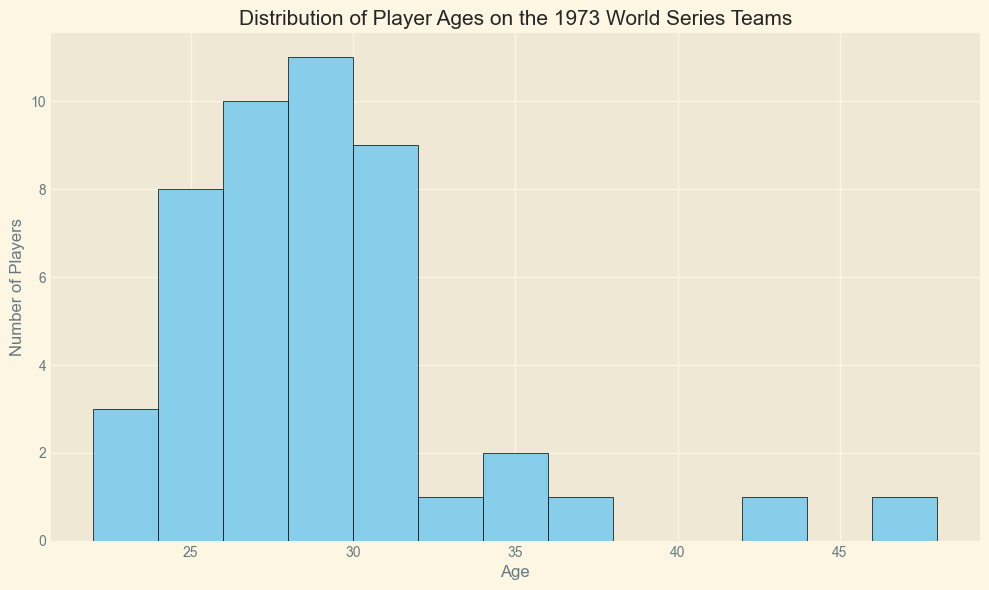What is the most common age among the players? By looking at the histogram, the age bin with the highest bar indicates the most common age. Count the bins and observe that the bar for age 29 is the tallest.
Answer: 29 How many players are 30 years old? Look at the height of the bar corresponding to the age bin that includes age 30. This bar reaches to 4 players.
Answer: 4 What is the age range of the players depicted in the histogram? Identify the lowest and highest age bins on the x-axis. The bins range from 22 to 48, so the player ages range from 23 to 47.
Answer: 23 to 47 Which team has the oldest player and how old is he? By noting the peak of the histogram and referring back to the data, the oldest player is Yogi Berra from the New York Mets at 47 years old.
Answer: New York Mets, 47 How many players are there in the 25-26 age range? Locate the bars for ages 25 and 26 and add their heights. The bars show heights of 4 and 5, respectively, summing to 9 players.
Answer: 9 What is the median age of the players? The median is the middle value when ages are ordered. With 48 players, the median will be the average of the 24th and 25th players. The histogram shows the ages are evenly distributed around age 28 and 29, so the median falls between them.
Answer: 28.5 Which age group (24-26 or 27-29) has more players? Sum the bar heights within each age group: 24-26 includes heights of 2, 4, 5 (total 11); 27-29 includes heights of 3, 1, 8 (total 12).
Answer: 27-29 What percentage of players are older than 35? Calculate the number of players older than 35 by adding the heights of the bars from age bins greater than 35 (35, 37, 42, 47). There are 2, 1, 1, and 1 players respectively, totaling 5. Divide by the total number of players (48) and multiply by 100 for the percentage.
Answer: 10.4% How does the representation of players aged 23 compare to those aged 31? Compare the height of the bars for age 23 (4 players) and age 31 (3 players).
Answer: More players aged 23 Are there more players in their 20s or in their 30s? Sum the heights of the bars for ages 20-29 and for ages 30-39. Ages 20-29 total 30 players; ages 30-39 total 13 players.
Answer: More players in their 20s 